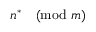Convert formula to latex. <formula><loc_0><loc_0><loc_500><loc_500>n ^ { * } { \pmod { m } }</formula> 